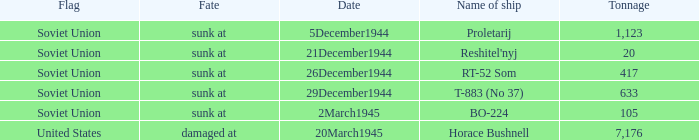What is the average tonnage of the ship named proletarij? 1123.0. 